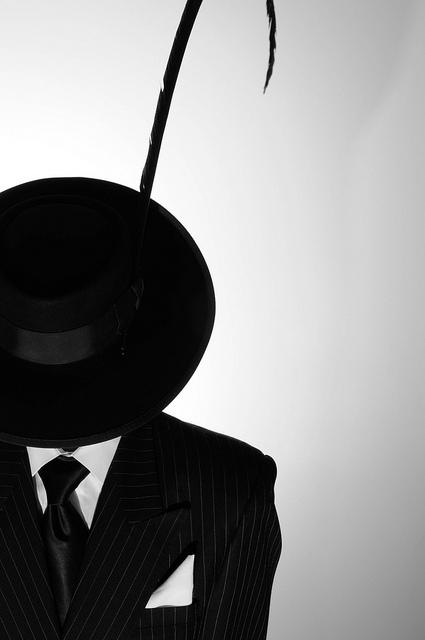What skinny black object is sticking up in the air?
Be succinct. Feather. Can you tell if the model is a real person or a mannequin?
Be succinct. No. What is the person wearing?
Keep it brief. Hat. 